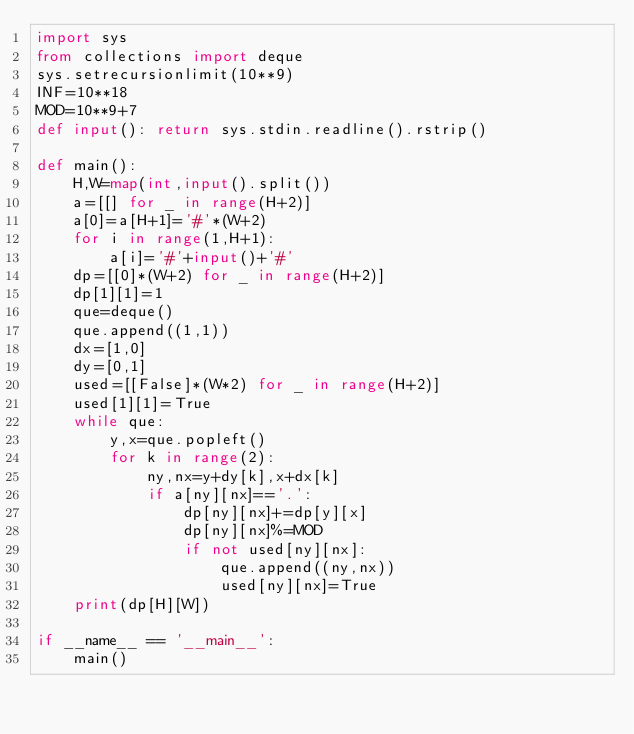Convert code to text. <code><loc_0><loc_0><loc_500><loc_500><_Python_>import sys
from collections import deque
sys.setrecursionlimit(10**9)
INF=10**18
MOD=10**9+7
def input(): return sys.stdin.readline().rstrip()

def main():
    H,W=map(int,input().split())
    a=[[] for _ in range(H+2)]
    a[0]=a[H+1]='#'*(W+2)
    for i in range(1,H+1):
        a[i]='#'+input()+'#'
    dp=[[0]*(W+2) for _ in range(H+2)]
    dp[1][1]=1
    que=deque()
    que.append((1,1))
    dx=[1,0]
    dy=[0,1]
    used=[[False]*(W*2) for _ in range(H+2)]
    used[1][1]=True
    while que:
        y,x=que.popleft()
        for k in range(2):
            ny,nx=y+dy[k],x+dx[k]
            if a[ny][nx]=='.':
                dp[ny][nx]+=dp[y][x]
                dp[ny][nx]%=MOD
                if not used[ny][nx]:
                    que.append((ny,nx))
                    used[ny][nx]=True
    print(dp[H][W])

if __name__ == '__main__':
    main()
</code> 